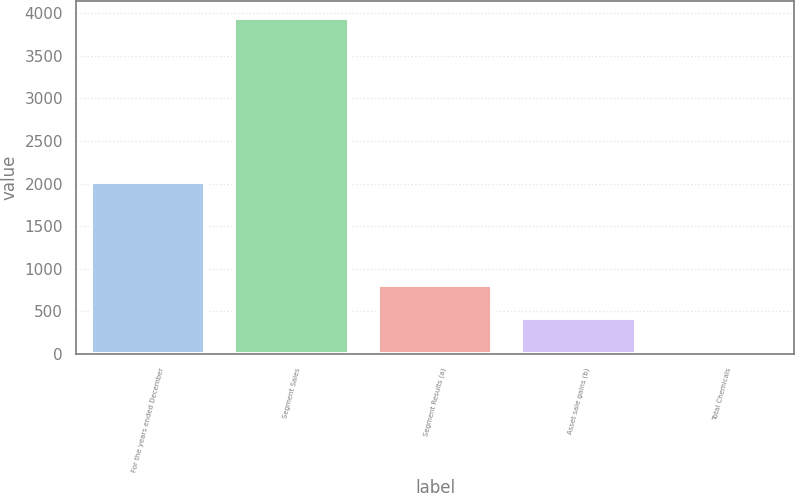<chart> <loc_0><loc_0><loc_500><loc_500><bar_chart><fcel>For the years ended December<fcel>Segment Sales<fcel>Segment Results (a)<fcel>Asset sale gains (b)<fcel>Total Chemicals<nl><fcel>2015<fcel>3945<fcel>807.4<fcel>415.2<fcel>23<nl></chart> 